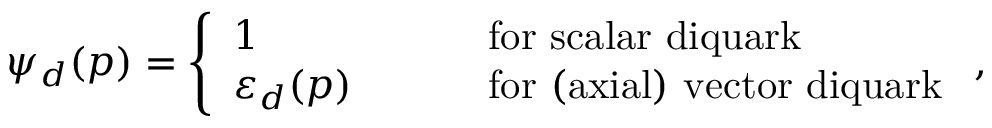Convert formula to latex. <formula><loc_0><loc_0><loc_500><loc_500>\psi _ { d } ( p ) = \left \{ \begin{array} { l l } { 1 } & { \quad f o r s c a l a r d i q u a r k } \\ { { \varepsilon _ { d } ( p ) } } & { \quad f o r ( a x i a l ) v e c t o r d i q u a r k } \end{array} ,</formula> 